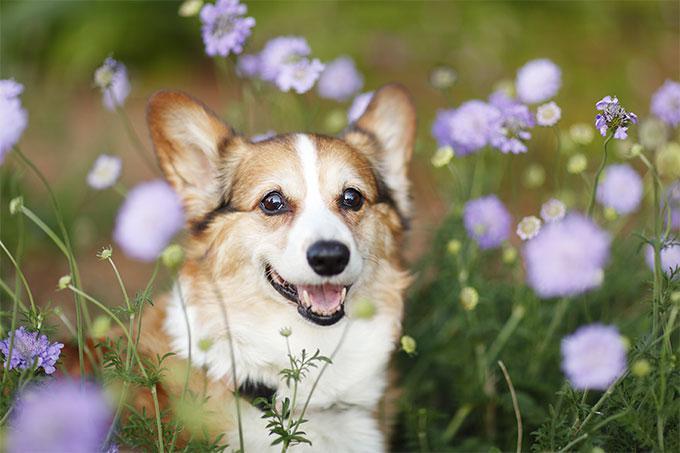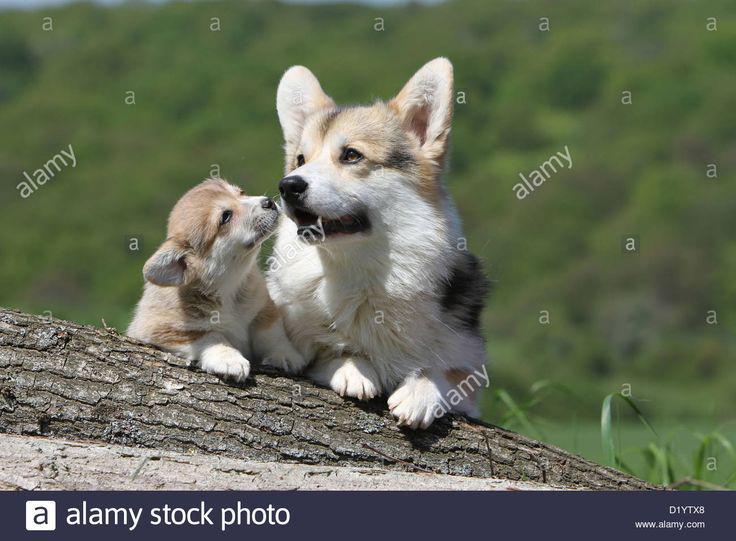The first image is the image on the left, the second image is the image on the right. For the images shown, is this caption "There are two dogs in the left image." true? Answer yes or no. No. 